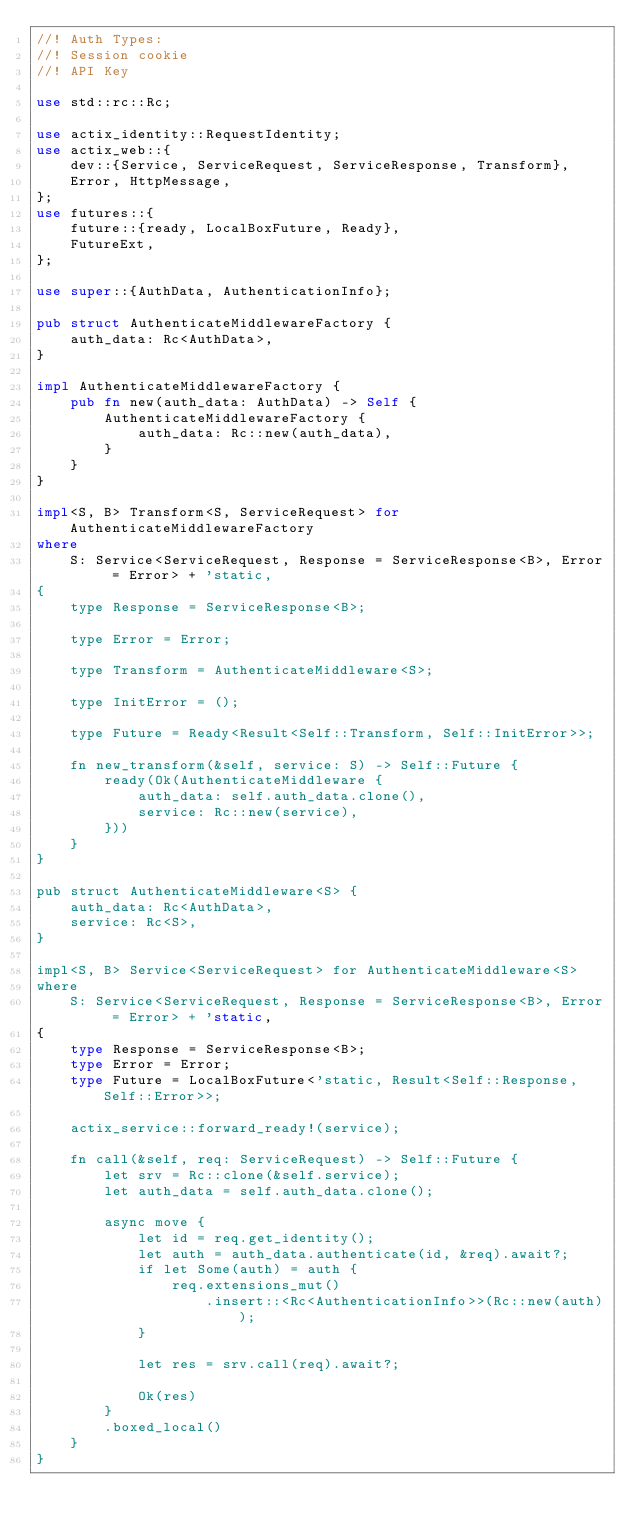Convert code to text. <code><loc_0><loc_0><loc_500><loc_500><_Rust_>//! Auth Types:
//! Session cookie
//! API Key

use std::rc::Rc;

use actix_identity::RequestIdentity;
use actix_web::{
    dev::{Service, ServiceRequest, ServiceResponse, Transform},
    Error, HttpMessage,
};
use futures::{
    future::{ready, LocalBoxFuture, Ready},
    FutureExt,
};

use super::{AuthData, AuthenticationInfo};

pub struct AuthenticateMiddlewareFactory {
    auth_data: Rc<AuthData>,
}

impl AuthenticateMiddlewareFactory {
    pub fn new(auth_data: AuthData) -> Self {
        AuthenticateMiddlewareFactory {
            auth_data: Rc::new(auth_data),
        }
    }
}

impl<S, B> Transform<S, ServiceRequest> for AuthenticateMiddlewareFactory
where
    S: Service<ServiceRequest, Response = ServiceResponse<B>, Error = Error> + 'static,
{
    type Response = ServiceResponse<B>;

    type Error = Error;

    type Transform = AuthenticateMiddleware<S>;

    type InitError = ();

    type Future = Ready<Result<Self::Transform, Self::InitError>>;

    fn new_transform(&self, service: S) -> Self::Future {
        ready(Ok(AuthenticateMiddleware {
            auth_data: self.auth_data.clone(),
            service: Rc::new(service),
        }))
    }
}

pub struct AuthenticateMiddleware<S> {
    auth_data: Rc<AuthData>,
    service: Rc<S>,
}

impl<S, B> Service<ServiceRequest> for AuthenticateMiddleware<S>
where
    S: Service<ServiceRequest, Response = ServiceResponse<B>, Error = Error> + 'static,
{
    type Response = ServiceResponse<B>;
    type Error = Error;
    type Future = LocalBoxFuture<'static, Result<Self::Response, Self::Error>>;

    actix_service::forward_ready!(service);

    fn call(&self, req: ServiceRequest) -> Self::Future {
        let srv = Rc::clone(&self.service);
        let auth_data = self.auth_data.clone();

        async move {
            let id = req.get_identity();
            let auth = auth_data.authenticate(id, &req).await?;
            if let Some(auth) = auth {
                req.extensions_mut()
                    .insert::<Rc<AuthenticationInfo>>(Rc::new(auth));
            }

            let res = srv.call(req).await?;

            Ok(res)
        }
        .boxed_local()
    }
}
</code> 